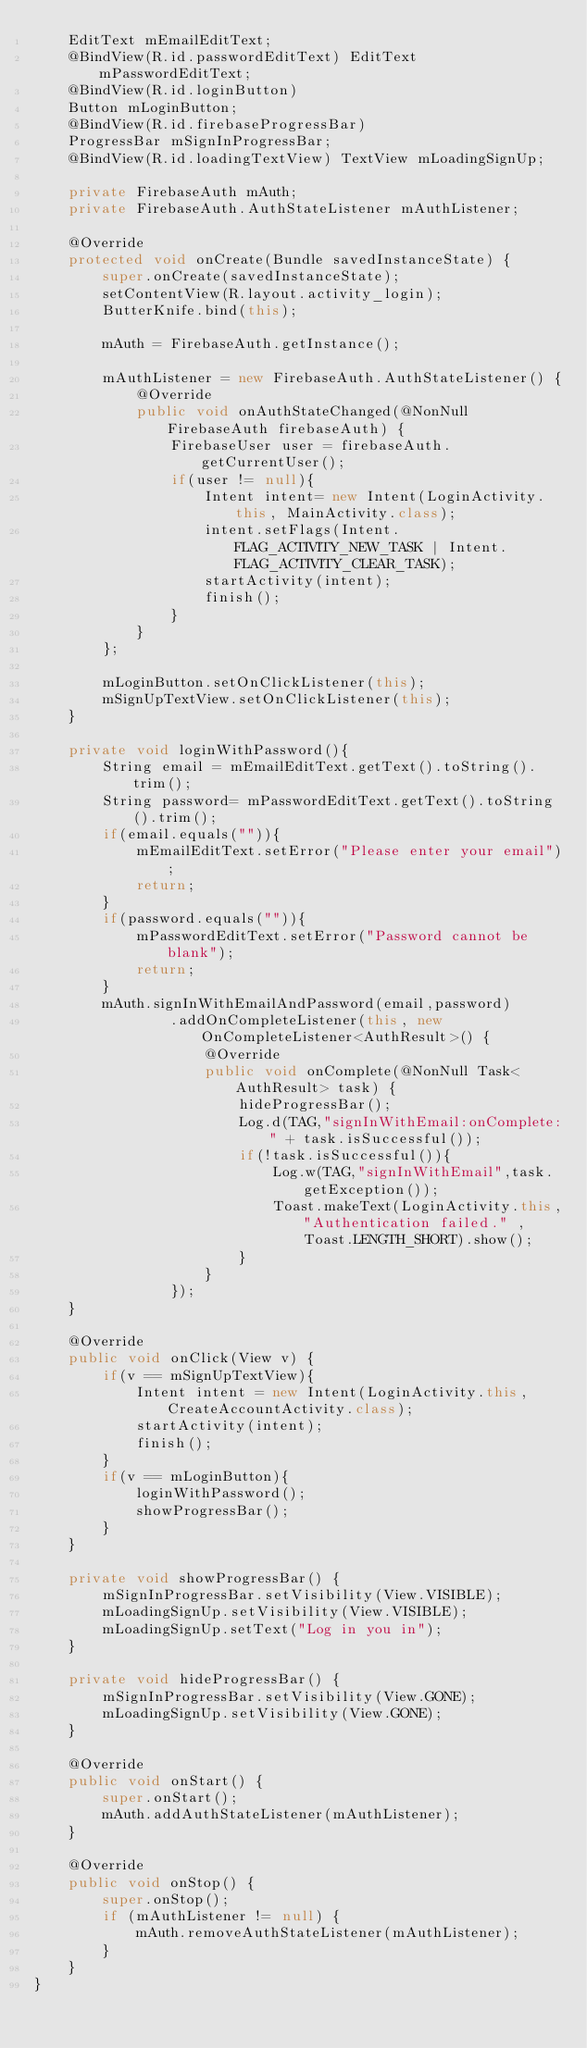<code> <loc_0><loc_0><loc_500><loc_500><_Java_>    EditText mEmailEditText;
    @BindView(R.id.passwordEditText) EditText mPasswordEditText;
    @BindView(R.id.loginButton)
    Button mLoginButton;
    @BindView(R.id.firebaseProgressBar)
    ProgressBar mSignInProgressBar;
    @BindView(R.id.loadingTextView) TextView mLoadingSignUp;

    private FirebaseAuth mAuth;
    private FirebaseAuth.AuthStateListener mAuthListener;

    @Override
    protected void onCreate(Bundle savedInstanceState) {
        super.onCreate(savedInstanceState);
        setContentView(R.layout.activity_login);
        ButterKnife.bind(this);

        mAuth = FirebaseAuth.getInstance();

        mAuthListener = new FirebaseAuth.AuthStateListener() {
            @Override
            public void onAuthStateChanged(@NonNull FirebaseAuth firebaseAuth) {
                FirebaseUser user = firebaseAuth.getCurrentUser();
                if(user != null){
                    Intent intent= new Intent(LoginActivity.this, MainActivity.class);
                    intent.setFlags(Intent.FLAG_ACTIVITY_NEW_TASK | Intent.FLAG_ACTIVITY_CLEAR_TASK);
                    startActivity(intent);
                    finish();
                }
            }
        };

        mLoginButton.setOnClickListener(this);
        mSignUpTextView.setOnClickListener(this);
    }

    private void loginWithPassword(){
        String email = mEmailEditText.getText().toString().trim();
        String password= mPasswordEditText.getText().toString().trim();
        if(email.equals("")){
            mEmailEditText.setError("Please enter your email");
            return;
        }
        if(password.equals("")){
            mPasswordEditText.setError("Password cannot be blank");
            return;
        }
        mAuth.signInWithEmailAndPassword(email,password)
                .addOnCompleteListener(this, new OnCompleteListener<AuthResult>() {
                    @Override
                    public void onComplete(@NonNull Task<AuthResult> task) {
                        hideProgressBar();
                        Log.d(TAG,"signInWithEmail:onComplete:" + task.isSuccessful());
                        if(!task.isSuccessful()){
                            Log.w(TAG,"signInWithEmail",task.getException());
                            Toast.makeText(LoginActivity.this,"Authentication failed." , Toast.LENGTH_SHORT).show();
                        }
                    }
                });
    }

    @Override
    public void onClick(View v) {
        if(v == mSignUpTextView){
            Intent intent = new Intent(LoginActivity.this,CreateAccountActivity.class);
            startActivity(intent);
            finish();
        }
        if(v == mLoginButton){
            loginWithPassword();
            showProgressBar();
        }
    }

    private void showProgressBar() {
        mSignInProgressBar.setVisibility(View.VISIBLE);
        mLoadingSignUp.setVisibility(View.VISIBLE);
        mLoadingSignUp.setText("Log in you in");
    }

    private void hideProgressBar() {
        mSignInProgressBar.setVisibility(View.GONE);
        mLoadingSignUp.setVisibility(View.GONE);
    }

    @Override
    public void onStart() {
        super.onStart();
        mAuth.addAuthStateListener(mAuthListener);
    }

    @Override
    public void onStop() {
        super.onStop();
        if (mAuthListener != null) {
            mAuth.removeAuthStateListener(mAuthListener);
        }
    }
}</code> 